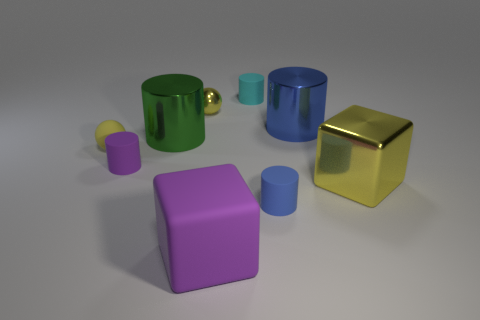Subtract all blue cubes. How many blue cylinders are left? 2 Subtract all shiny cylinders. How many cylinders are left? 3 Subtract all cubes. How many objects are left? 7 Subtract 1 cubes. How many cubes are left? 1 Subtract all green cylinders. How many cylinders are left? 4 Subtract all yellow blocks. Subtract all green cylinders. How many blocks are left? 1 Subtract all metal things. Subtract all small blue cylinders. How many objects are left? 4 Add 5 matte cylinders. How many matte cylinders are left? 8 Add 7 small yellow metallic things. How many small yellow metallic things exist? 8 Subtract 0 green blocks. How many objects are left? 9 